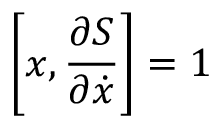<formula> <loc_0><loc_0><loc_500><loc_500>\left [ x , { \frac { \partial S } { \partial { \dot { x } } } } \right ] = 1</formula> 